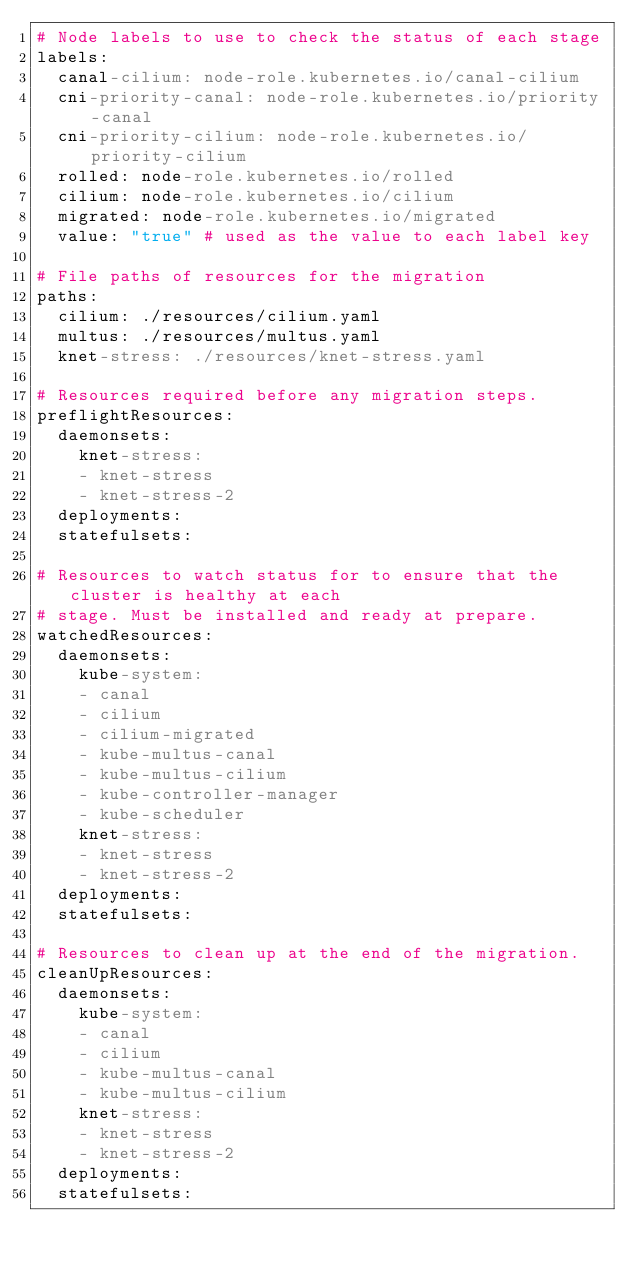<code> <loc_0><loc_0><loc_500><loc_500><_YAML_># Node labels to use to check the status of each stage
labels:
  canal-cilium: node-role.kubernetes.io/canal-cilium
  cni-priority-canal: node-role.kubernetes.io/priority-canal
  cni-priority-cilium: node-role.kubernetes.io/priority-cilium
  rolled: node-role.kubernetes.io/rolled
  cilium: node-role.kubernetes.io/cilium
  migrated: node-role.kubernetes.io/migrated
  value: "true" # used as the value to each label key

# File paths of resources for the migration
paths:
  cilium: ./resources/cilium.yaml
  multus: ./resources/multus.yaml
  knet-stress: ./resources/knet-stress.yaml

# Resources required before any migration steps.
preflightResources:
  daemonsets:
    knet-stress:
    - knet-stress
    - knet-stress-2
  deployments:
  statefulsets:

# Resources to watch status for to ensure that the cluster is healthy at each
# stage. Must be installed and ready at prepare.
watchedResources:
  daemonsets:
    kube-system:
    - canal
    - cilium
    - cilium-migrated
    - kube-multus-canal
    - kube-multus-cilium
    - kube-controller-manager
    - kube-scheduler
    knet-stress:
    - knet-stress
    - knet-stress-2
  deployments:
  statefulsets:

# Resources to clean up at the end of the migration.
cleanUpResources:
  daemonsets:
    kube-system:
    - canal
    - cilium
    - kube-multus-canal
    - kube-multus-cilium
    knet-stress:
    - knet-stress
    - knet-stress-2
  deployments:
  statefulsets:
</code> 